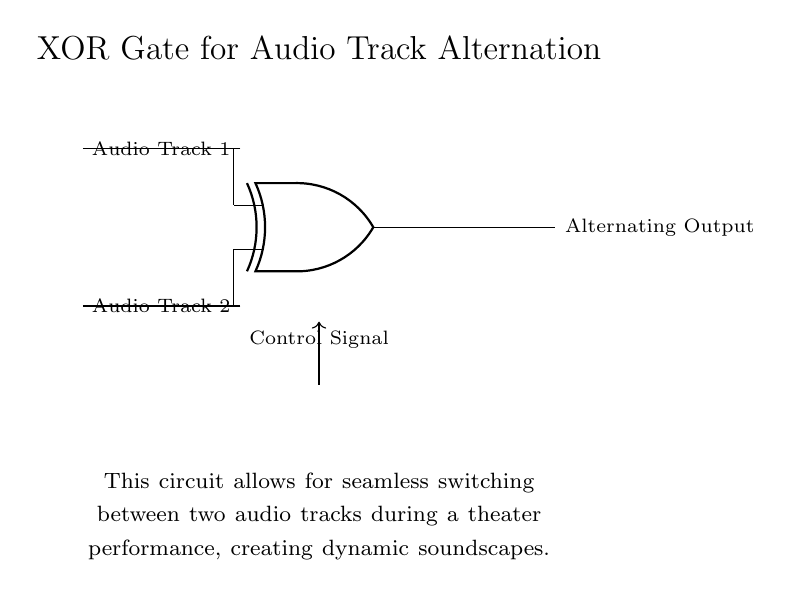What are the two input audio tracks for this circuit? The circuit shows two input lines labeled as Audio Track 1 and Audio Track 2. These are clearly indicated, with one on the top and the other on the bottom of the XOR gate.
Answer: Audio Track 1 and Audio Track 2 What is the output of the XOR gate? The output line is labeled "Alternating Output," which indicates that the circuit's function is to provide an alternating audio signal based on the inputs.
Answer: Alternating Output What role does the control signal play in this circuit? The control signal influences which audio track is output by the XOR gate. It can switch the input signals, thus determining the output based on the state of the control signal.
Answer: Determines the output How many inputs does the XOR gate have? The diagram explicitly shows two input lines connecting to the XOR gate, confirmed by the inlets marked on the gate itself.
Answer: Two What happens to the output signal when both audio tracks are active? The XOR gate logic dictates that if both inputs (Audio Track 1 and 2) are active (high signal), the output will be low (inactive), as XOR only outputs high when one input is true.
Answer: Output is low What is the purpose of using an XOR gate in this circuit? The XOR gate enables the dynamic alternation between two audio tracks, allowing for a creative sound transition during the performance. This gate is uniquely suited for toggling states between the two audio inputs based on the control signal.
Answer: Seamless audio track switching 